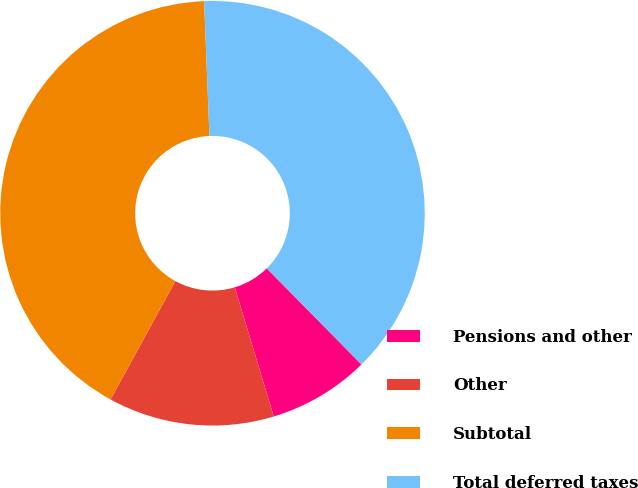Convert chart. <chart><loc_0><loc_0><loc_500><loc_500><pie_chart><fcel>Pensions and other<fcel>Other<fcel>Subtotal<fcel>Total deferred taxes<nl><fcel>7.72%<fcel>12.63%<fcel>41.4%<fcel>38.24%<nl></chart> 